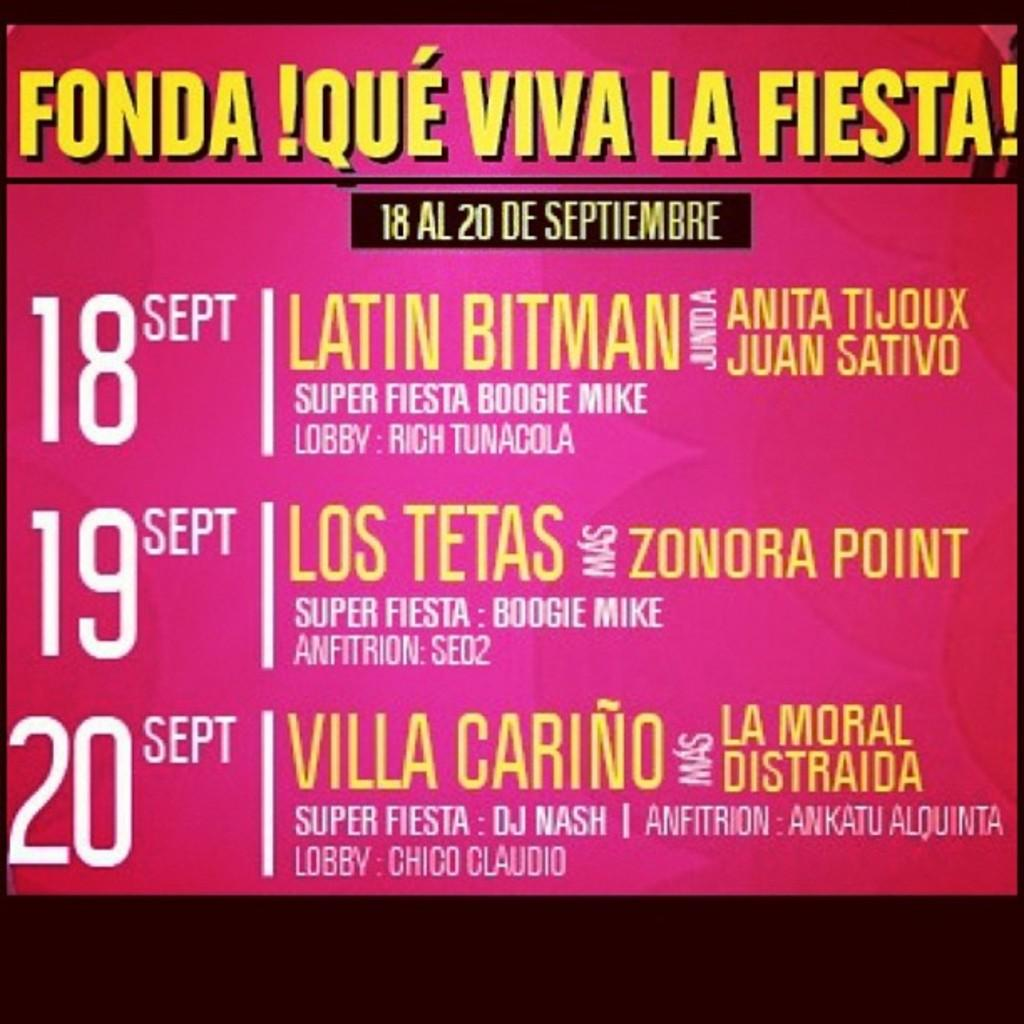<image>
Present a compact description of the photo's key features. a poster that says 'fonda! que viva la fiesta!' on it 